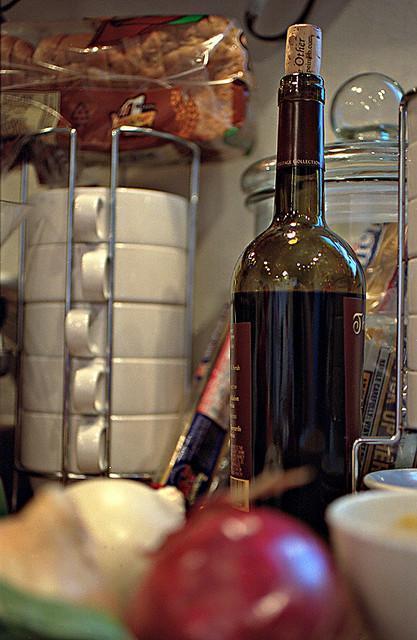How many coffee cups are in the rack?
Give a very brief answer. 5. How many apples are visible?
Give a very brief answer. 1. How many cups are in the picture?
Give a very brief answer. 5. 